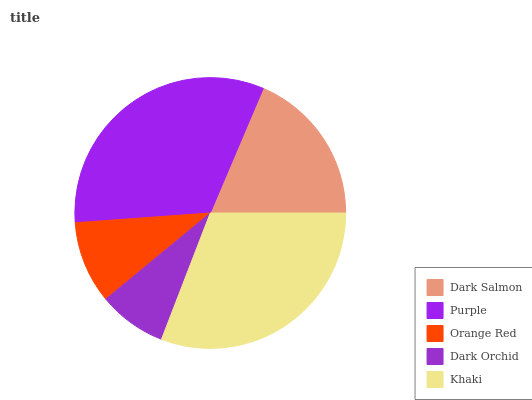Is Dark Orchid the minimum?
Answer yes or no. Yes. Is Purple the maximum?
Answer yes or no. Yes. Is Orange Red the minimum?
Answer yes or no. No. Is Orange Red the maximum?
Answer yes or no. No. Is Purple greater than Orange Red?
Answer yes or no. Yes. Is Orange Red less than Purple?
Answer yes or no. Yes. Is Orange Red greater than Purple?
Answer yes or no. No. Is Purple less than Orange Red?
Answer yes or no. No. Is Dark Salmon the high median?
Answer yes or no. Yes. Is Dark Salmon the low median?
Answer yes or no. Yes. Is Khaki the high median?
Answer yes or no. No. Is Dark Orchid the low median?
Answer yes or no. No. 